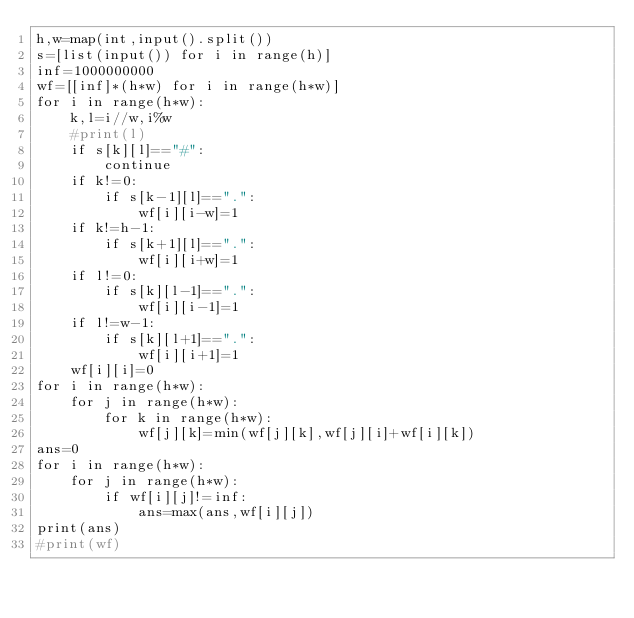<code> <loc_0><loc_0><loc_500><loc_500><_Python_>h,w=map(int,input().split())
s=[list(input()) for i in range(h)]
inf=1000000000
wf=[[inf]*(h*w) for i in range(h*w)]
for i in range(h*w):
    k,l=i//w,i%w
    #print(l)
    if s[k][l]=="#":
        continue
    if k!=0:
        if s[k-1][l]==".":
            wf[i][i-w]=1
    if k!=h-1:
        if s[k+1][l]==".":
            wf[i][i+w]=1
    if l!=0:
        if s[k][l-1]==".":
            wf[i][i-1]=1
    if l!=w-1:
        if s[k][l+1]==".":
            wf[i][i+1]=1
    wf[i][i]=0
for i in range(h*w):
    for j in range(h*w):
        for k in range(h*w):
            wf[j][k]=min(wf[j][k],wf[j][i]+wf[i][k])
ans=0
for i in range(h*w):
    for j in range(h*w):
        if wf[i][j]!=inf:
            ans=max(ans,wf[i][j])
print(ans)
#print(wf)</code> 